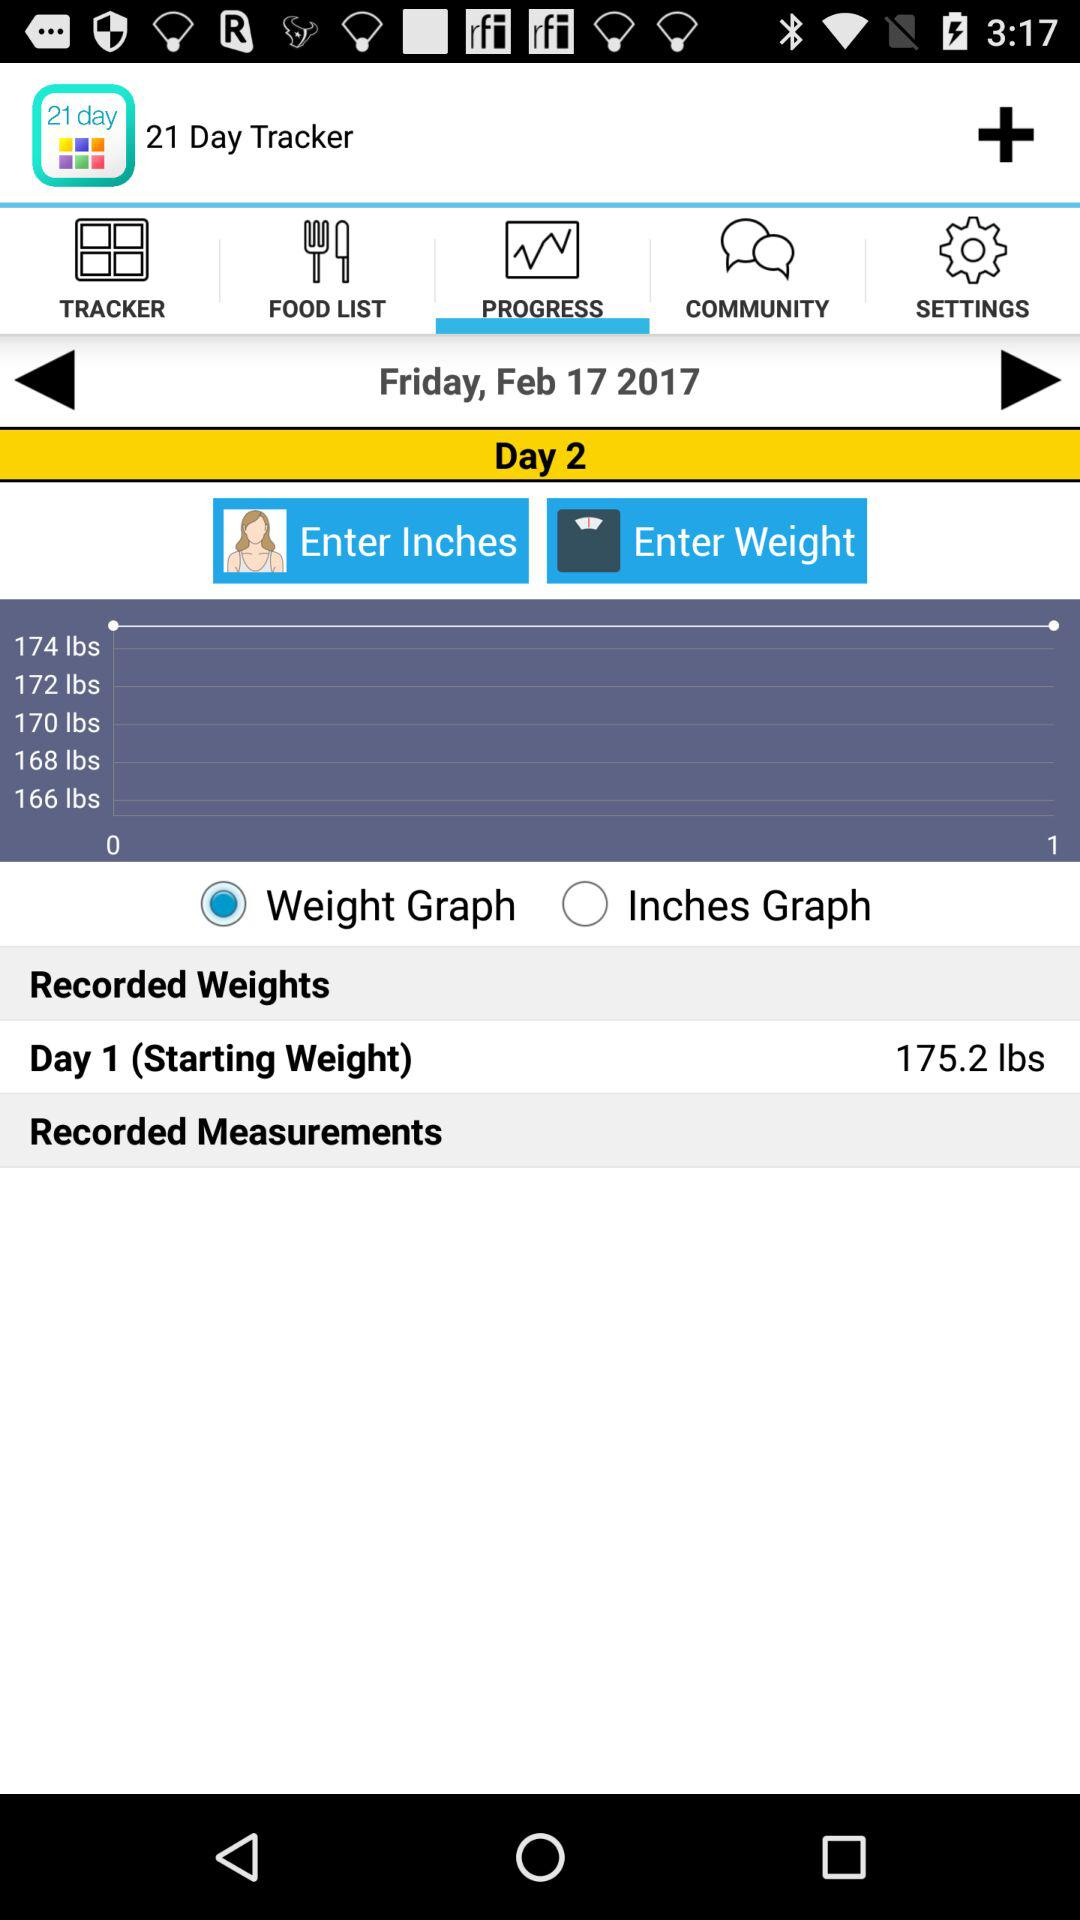Which option is selected there? The selected options are "PROGRESS" and "Weight Graph". 